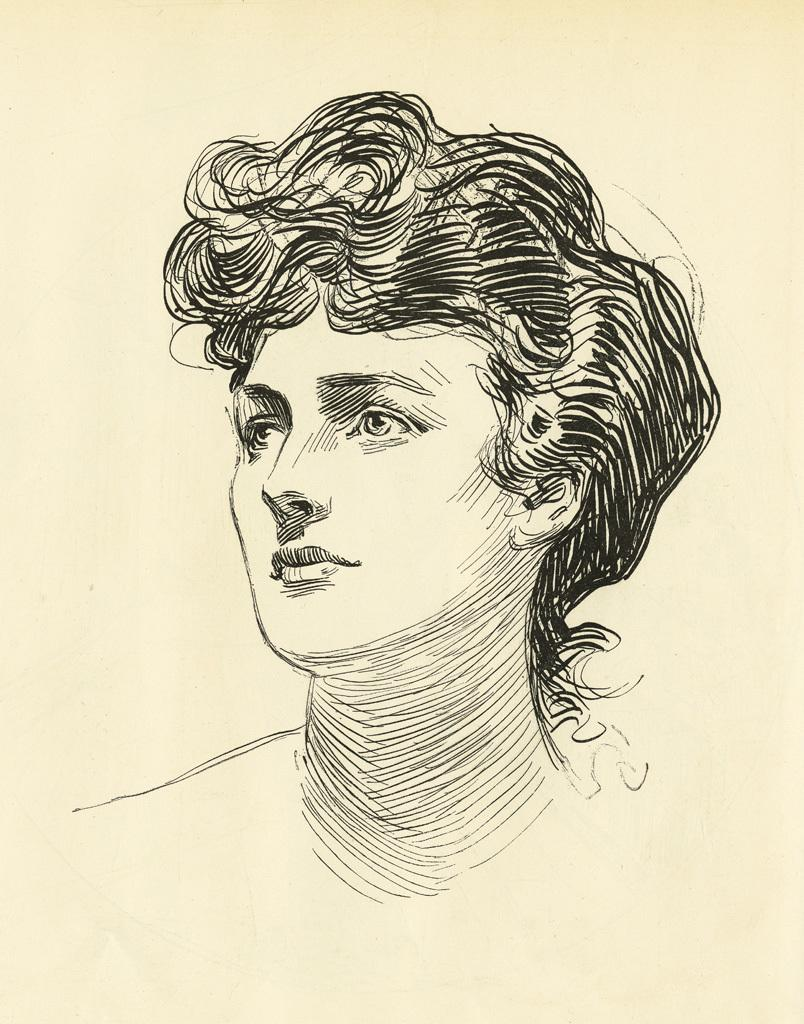What is depicted in the image? There is a sketch of a person in the image. What is the medium of the artwork? The sketch is on a surface. What type of pancake is being served in the image? There is no pancake present in the image; it features a sketch of a person on a surface. 